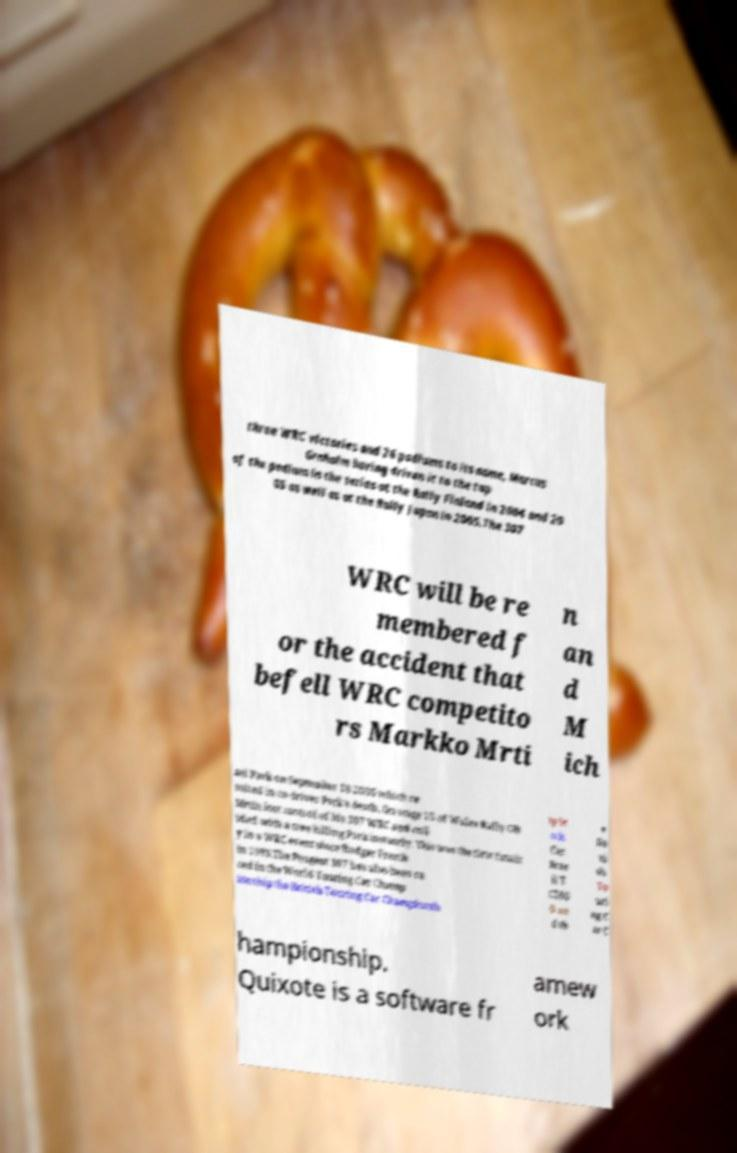What messages or text are displayed in this image? I need them in a readable, typed format. three WRC victories and 26 podiums to its name, Marcus Grnholm having driven it to the top of the podium in the series at the Rally Finland in 2004 and 20 05 as well as at the Rally Japan in 2005.The 307 WRC will be re membered f or the accident that befell WRC competito rs Markko Mrti n an d M ich ael Park on September 18 2005 which re sulted in co-driver Park's death. On stage 15 of Wales Rally GB Mrtin lost control of his 307 WRC and coll ided with a tree killing Park instantly. This was the first fatalit y in a WRC event since Rodger Freeth in 1993.The Peugeot 307 has also been ra ced in the World Touring Car Champ ionship the British Touring Car Championsh ip St ock Car Bras il T C200 0 an d th e Da ni sh To uri ng C ar C hampionship. Quixote is a software fr amew ork 